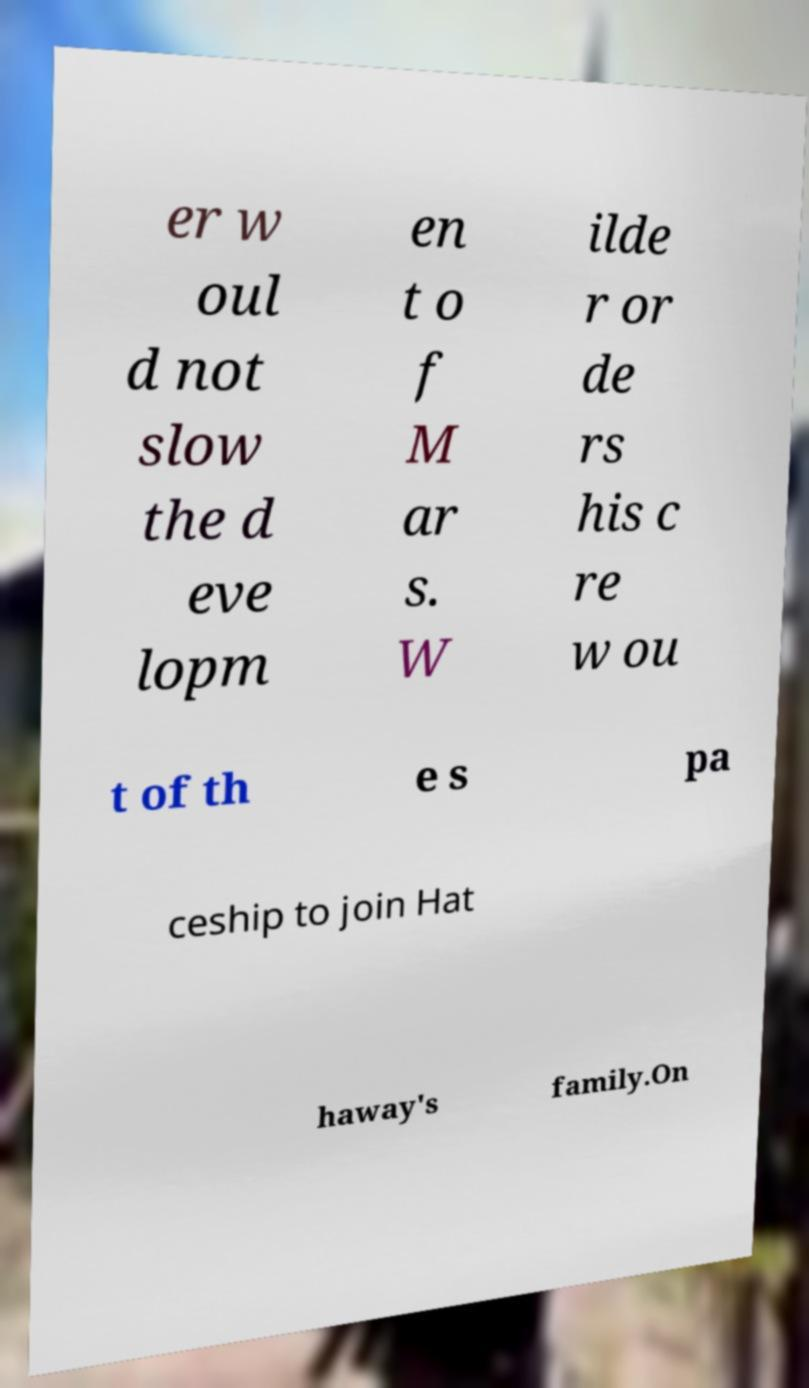Could you extract and type out the text from this image? er w oul d not slow the d eve lopm en t o f M ar s. W ilde r or de rs his c re w ou t of th e s pa ceship to join Hat haway's family.On 